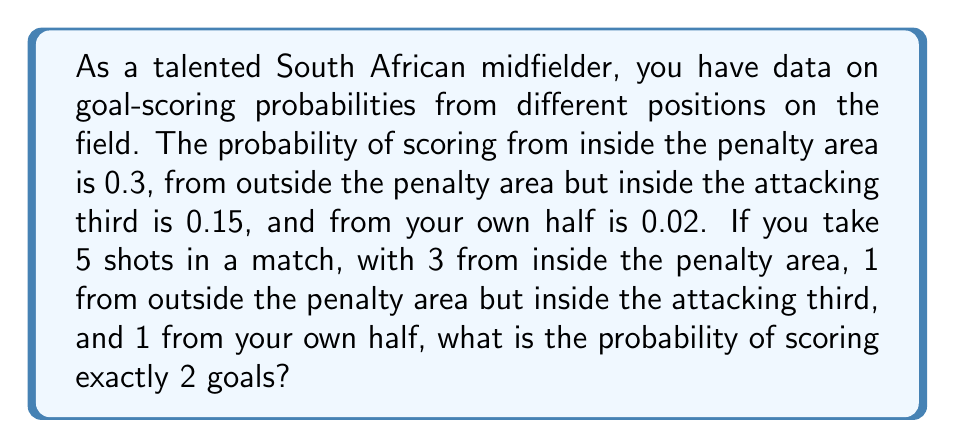Provide a solution to this math problem. Let's approach this step-by-step using the binomial probability distribution:

1) We have 5 independent trials (shots) with different probabilities of success (scoring).

2) We need to calculate the probability of exactly 2 successes out of these 5 trials.

3) We can use the concept of conditional probability and the law of total probability.

4) Let's define events:
   A: Score from inside the penalty area
   B: Score from outside penalty area but inside attacking third
   C: Score from own half

5) We need to consider all possible ways to score exactly 2 goals:
   - 2 from A, 0 from B, 0 from C
   - 1 from A, 1 from B, 0 from C
   - 1 from A, 0 from B, 1 from C
   - 0 from A, 1 from B, 1 from C

6) Probability for each scenario:

   P(2A, 0B, 0C) = $\binom{3}{2}(0.3)^2(0.7)^1 \cdot (0.85)^1 \cdot (0.98)^1$
                 = $3 \cdot 0.09 \cdot 0.7 \cdot 0.85 \cdot 0.98$
                 = $0.15683$

   P(1A, 1B, 0C) = $\binom{3}{1}(0.3)^1(0.7)^2 \cdot (0.15)^1 \cdot (0.98)^1$
                 = $3 \cdot 0.3 \cdot 0.49 \cdot 0.15 \cdot 0.98$
                 = $0.06468$

   P(1A, 0B, 1C) = $\binom{3}{1}(0.3)^1(0.7)^2 \cdot (0.85)^1 \cdot (0.02)^1$
                 = $3 \cdot 0.3 \cdot 0.49 \cdot 0.85 \cdot 0.02$
                 = $0.00749$

   P(0A, 1B, 1C) = $(0.7)^3 \cdot (0.15)^1 \cdot (0.02)^1$
                 = $0.343 \cdot 0.15 \cdot 0.02$
                 = $0.001029$

7) Total probability of scoring exactly 2 goals:
   $P(\text{2 goals}) = 0.15683 + 0.06468 + 0.00749 + 0.001029 = 0.23003$
Answer: $0.23003$ 